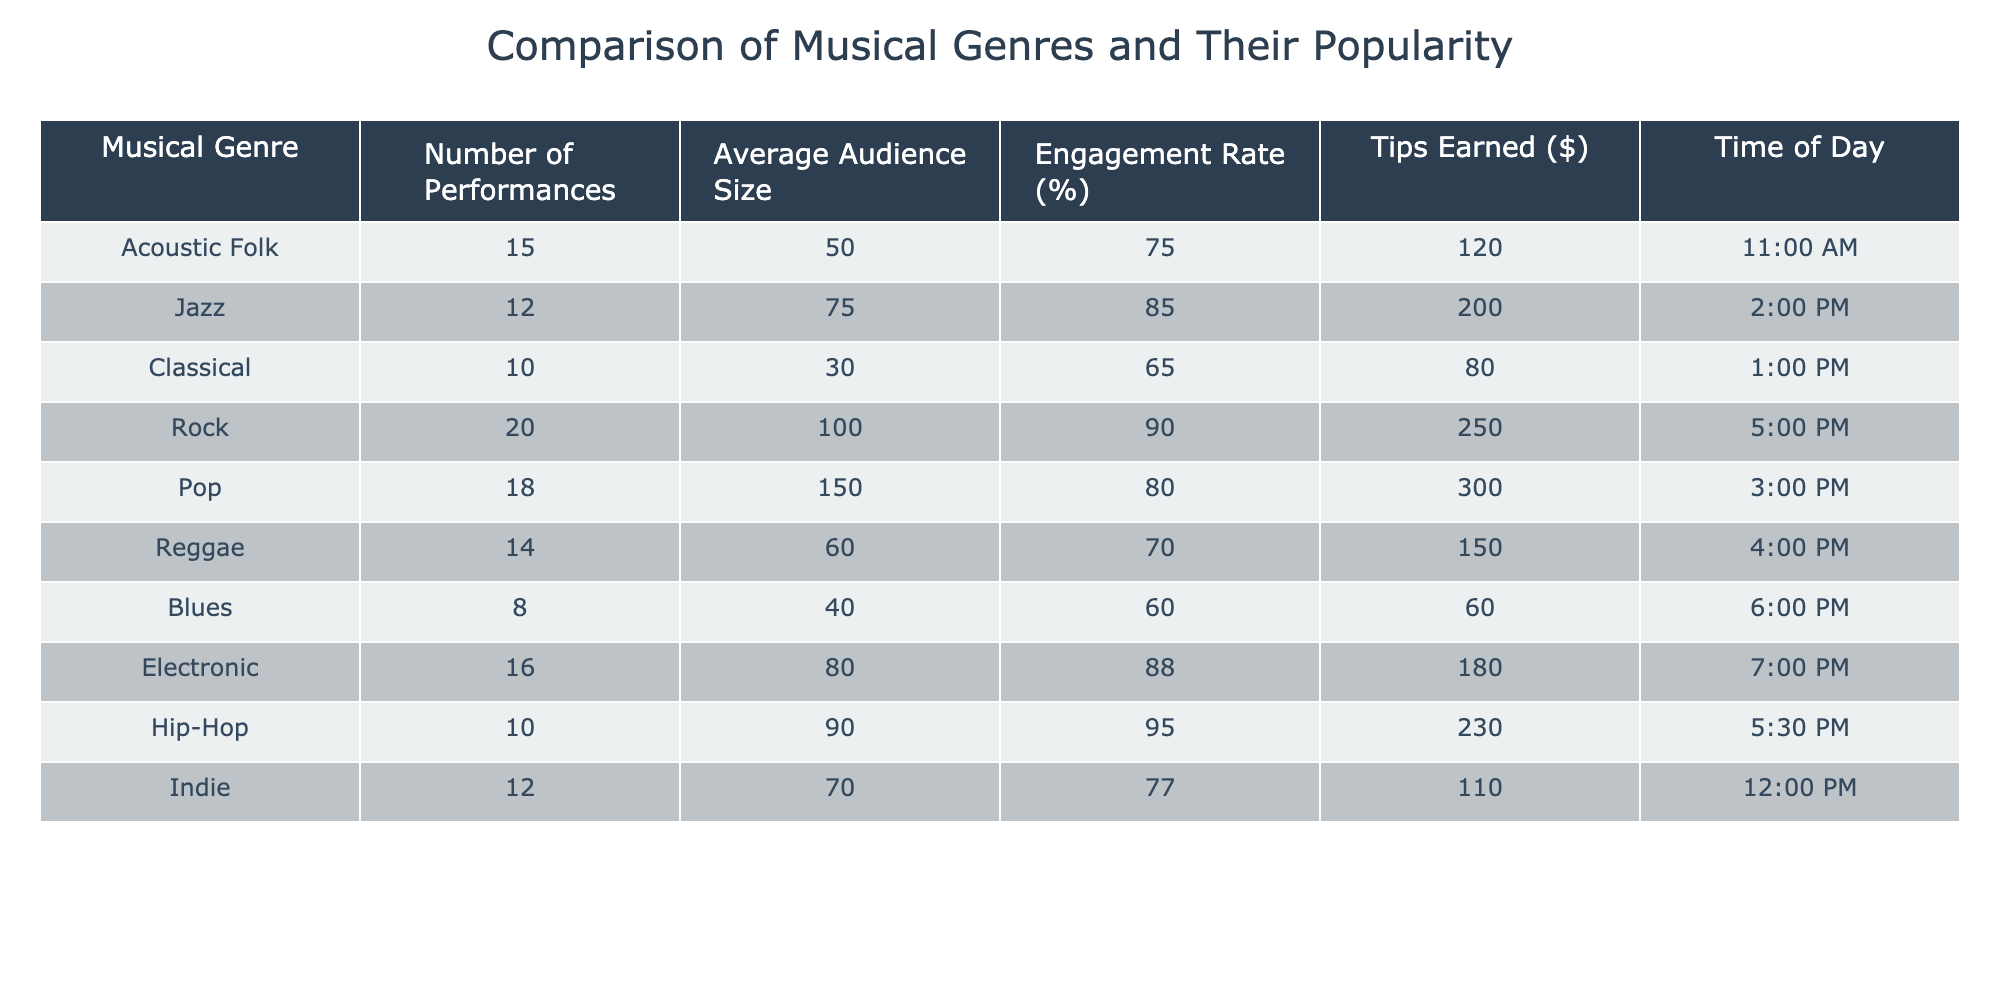What is the engagement rate for Jazz? The engagement rate for Jazz can be found directly in the table under the "Engagement Rate (%)" column beside the "Jazz" row. It shows 85%.
Answer: 85 Which genre had the highest average audience size? To determine the genre with the highest average audience size, we compare the "Average Audience Size" values across all genres. The maximum value is 150, corresponding to the "Pop" genre.
Answer: Pop What is the total number of performances for Rock and Pop combined? We need to find the number of performances for both Rock and Pop in the table. Rock has 20 performances and Pop has 18 performances. Summing these gives us 20 + 18 = 38.
Answer: 38 Is the average engagement rate for Acoustic Folk higher than that for Blues? The engagement rate for Acoustic Folk is 75% and for Blues, it is 60%. Since 75% is greater than 60%, the statement is true.
Answer: Yes What is the difference in tips earned between the genre with the highest tips earned and the genre with the lowest tips earned? First, we identify the tips earned for each genre. The highest is 300 from Pop, and the lowest is 60 from Blues. The difference is 300 - 60 = 240.
Answer: 240 Which time of day had the highest average audience size? We have to look at the "Average Audience Size" values along with their corresponding times. The highest average audience size is 150 for Pop at 3:00 PM.
Answer: 3:00 PM How many genres have an engagement rate greater than 80%? We check the "Engagement Rate (%)" column to see how many genres exceed 80%. The genres with rates above 80% are Jazz (85%), Rock (90%), Pop (80%), and Hip-Hop (95%). There are four genres in total.
Answer: 4 What is the average engagement rate across all genres? To find the average engagement rate, we sum the engagement rates for all genres: (75 + 85 + 65 + 90 + 80 + 70 + 60 + 88 + 95 + 77) = 815. There are 10 genres, so the average is 815 / 10 = 81.5.
Answer: 81.5 Does the time of day affect the average audience size? To assess if time affects audience size, we look for trends in "Average Audience Size" based on different times. From the data, we observe variations, indicating that time does impact audience size.
Answer: Yes 